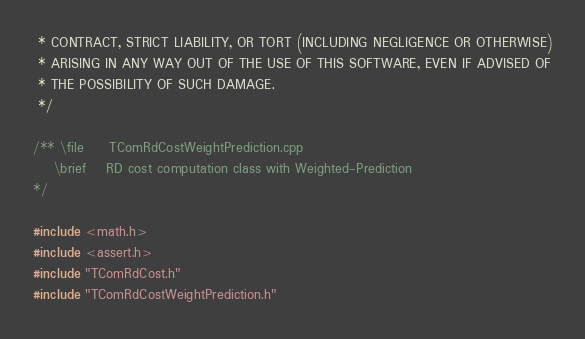Convert code to text. <code><loc_0><loc_0><loc_500><loc_500><_C++_> * CONTRACT, STRICT LIABILITY, OR TORT (INCLUDING NEGLIGENCE OR OTHERWISE)
 * ARISING IN ANY WAY OUT OF THE USE OF THIS SOFTWARE, EVEN IF ADVISED OF
 * THE POSSIBILITY OF SUCH DAMAGE.
 */

/** \file     TComRdCostWeightPrediction.cpp
    \brief    RD cost computation class with Weighted-Prediction
*/

#include <math.h>
#include <assert.h>
#include "TComRdCost.h"
#include "TComRdCostWeightPrediction.h"
</code> 